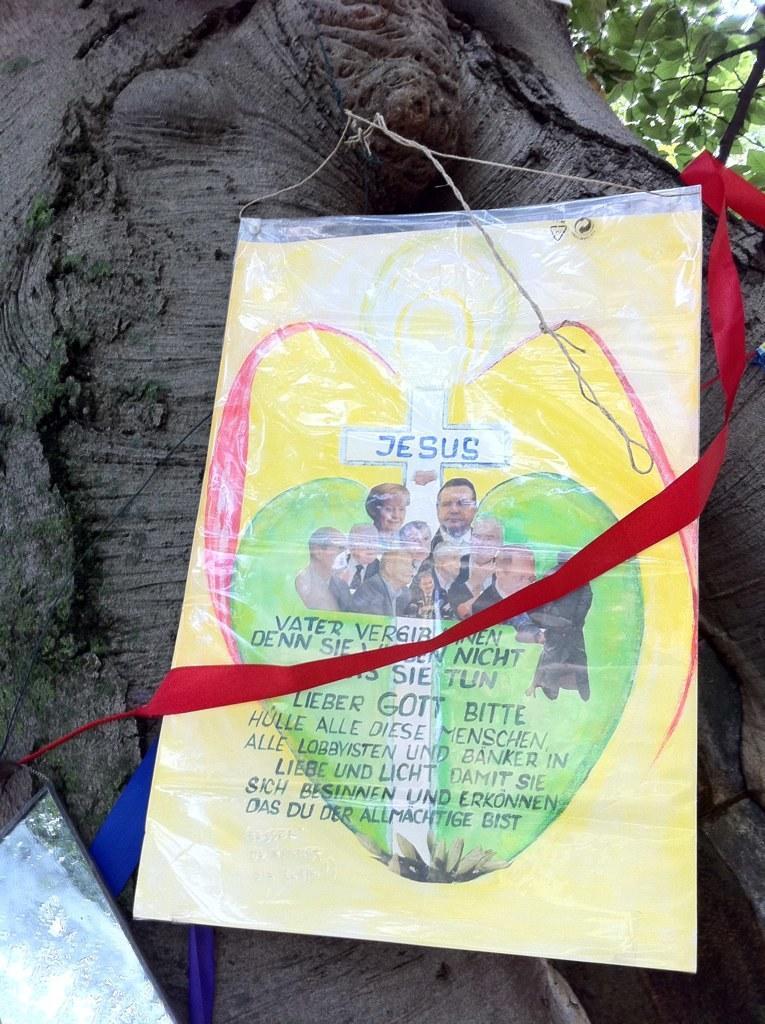Can you describe this image briefly? In this picture there is a paper which has something written on it is tightened to a tree and there are some other objects beside it. 